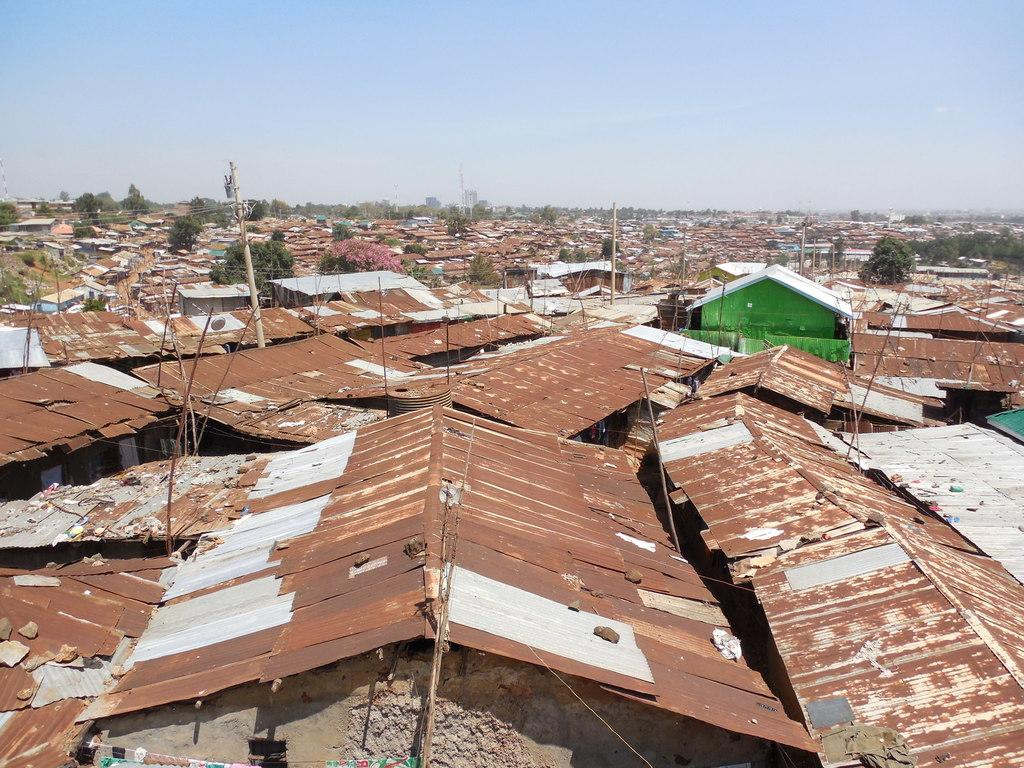What type of structures can be seen in the image? There are sheds and houses in the image. What type of natural elements are present in the image? There are trees in the image. What man-made objects can be seen in the image? There are poles in the image. What type of skirt is the frog wearing in the image? There is no frog or skirt present in the image. 